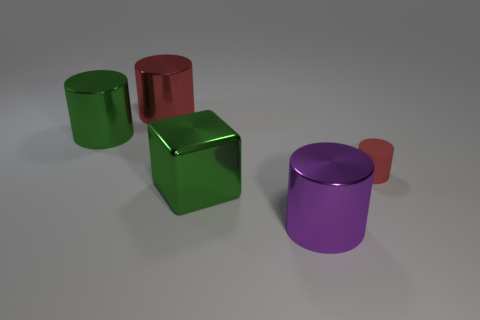Is there anything else that is the same size as the rubber cylinder?
Give a very brief answer. No. There is a green object that is the same shape as the big purple shiny object; what size is it?
Provide a succinct answer. Large. Are there more green objects that are to the right of the red matte cylinder than red metallic things?
Provide a short and direct response. No. Are the big green thing that is in front of the small red object and the purple cylinder made of the same material?
Offer a terse response. Yes. There is a metal cylinder behind the large green metallic object behind the tiny cylinder in front of the red metallic thing; how big is it?
Your answer should be very brief. Large. What is the size of the green block that is the same material as the big purple cylinder?
Ensure brevity in your answer.  Large. What is the color of the metallic thing that is both in front of the large red object and left of the green metal cube?
Offer a terse response. Green. There is a metal object in front of the green shiny block; is it the same shape as the red object on the right side of the cube?
Make the answer very short. Yes. There is a green object that is to the left of the large red cylinder; what is it made of?
Keep it short and to the point. Metal. What size is the cylinder that is the same color as the big metal cube?
Your answer should be very brief. Large. 